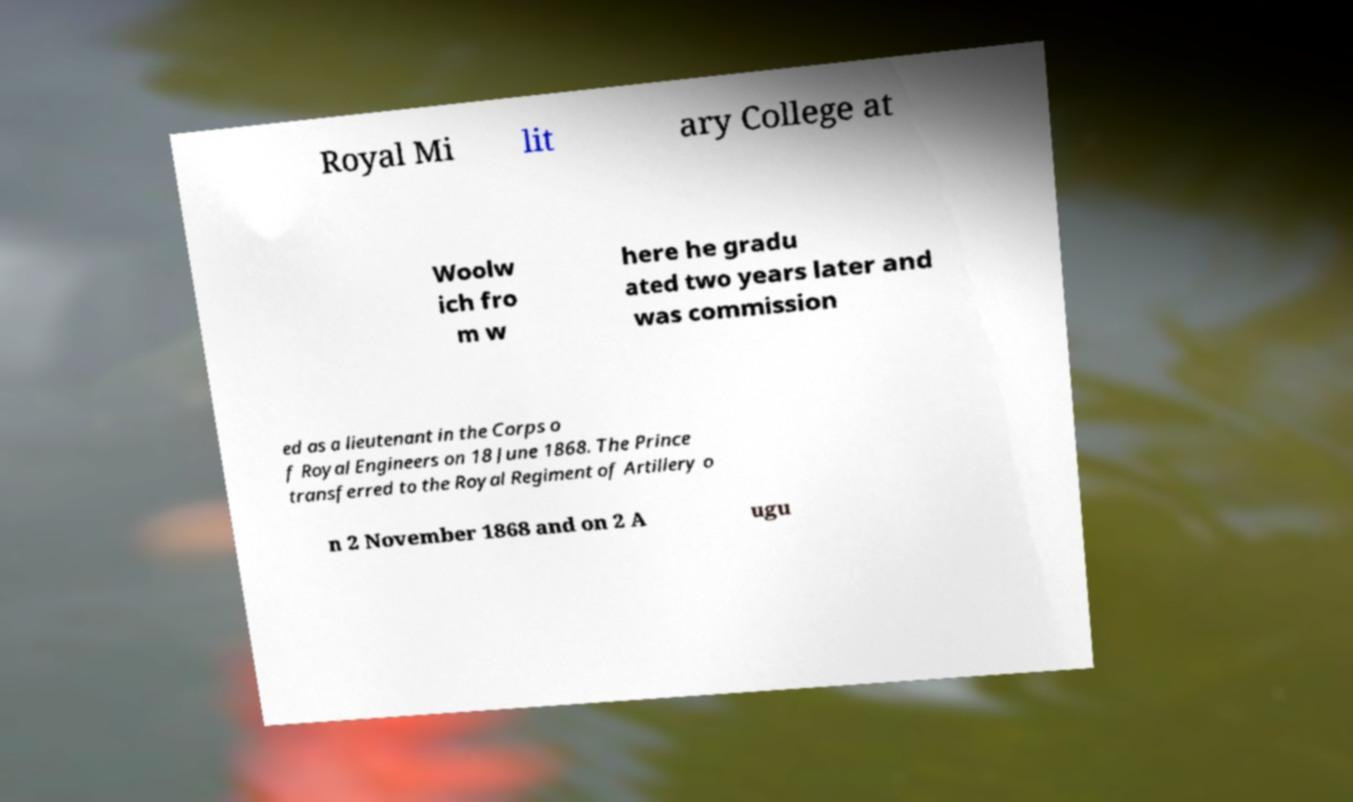Please identify and transcribe the text found in this image. Royal Mi lit ary College at Woolw ich fro m w here he gradu ated two years later and was commission ed as a lieutenant in the Corps o f Royal Engineers on 18 June 1868. The Prince transferred to the Royal Regiment of Artillery o n 2 November 1868 and on 2 A ugu 